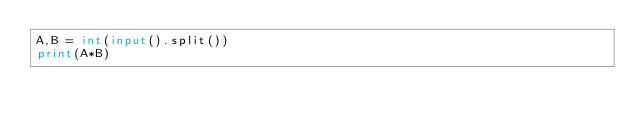Convert code to text. <code><loc_0><loc_0><loc_500><loc_500><_Python_>A,B = int(input().split())
print(A*B)</code> 